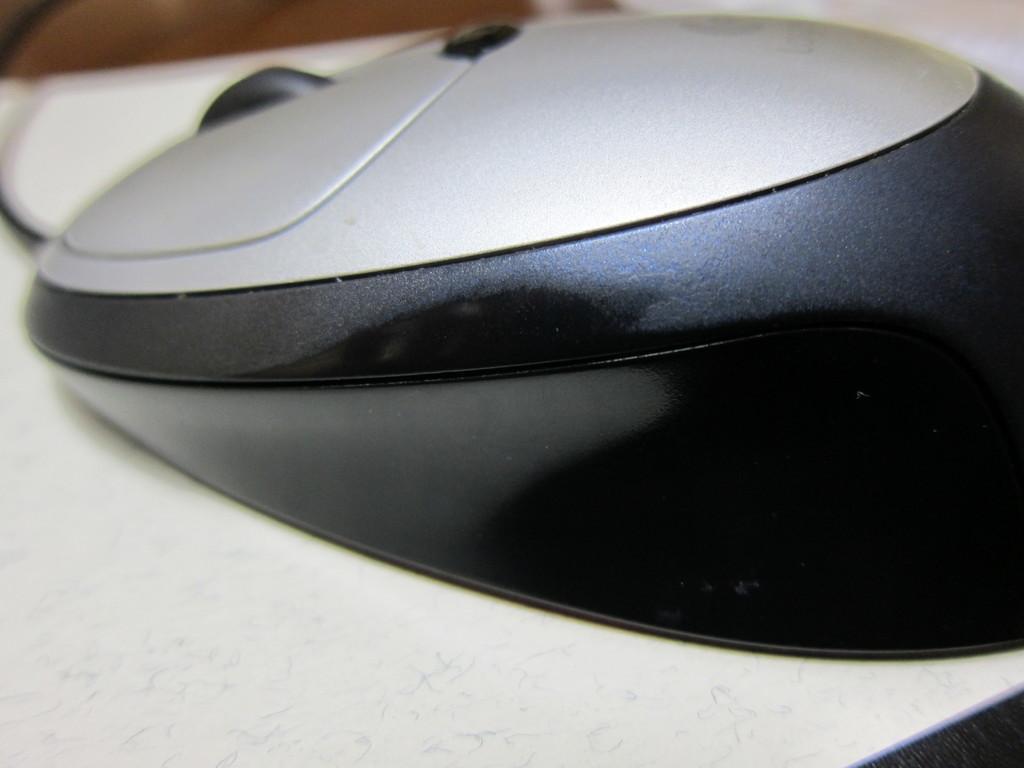Could you give a brief overview of what you see in this image? In this picture I can see a mouse on an object. 